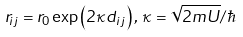<formula> <loc_0><loc_0><loc_500><loc_500>r _ { i j } = r _ { 0 } \exp \left ( 2 \kappa d _ { i j } \right ) , \, \kappa = \sqrt { 2 m U } / \hbar</formula> 